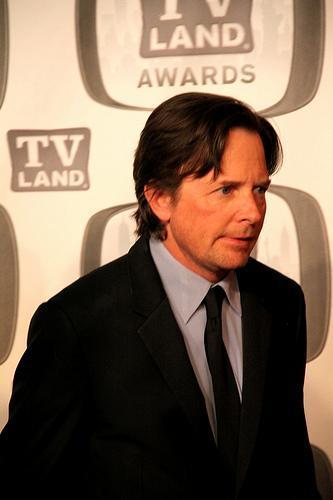How many people are there?
Give a very brief answer. 1. 